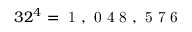Convert formula to latex. <formula><loc_0><loc_0><loc_500><loc_500>3 2 ^ { 4 } = 1 , 0 4 8 , 5 7 6</formula> 